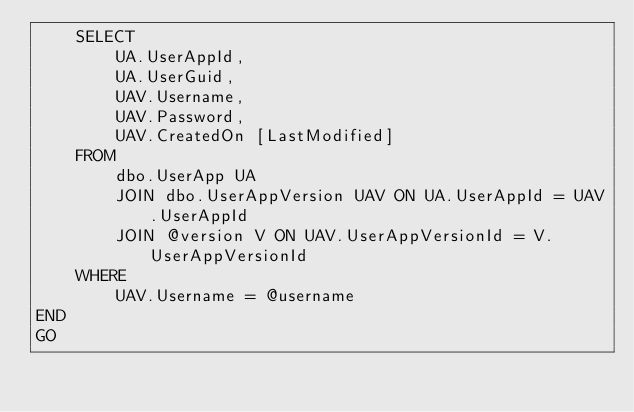Convert code to text. <code><loc_0><loc_0><loc_500><loc_500><_SQL_>    SELECT
        UA.UserAppId,
        UA.UserGuid,
        UAV.Username,
        UAV.Password,
        UAV.CreatedOn [LastModified]
    FROM
        dbo.UserApp UA
        JOIN dbo.UserAppVersion UAV ON UA.UserAppId = UAV.UserAppId
        JOIN @version V ON UAV.UserAppVersionId = V.UserAppVersionId
    WHERE
        UAV.Username = @username
END
GO
</code> 